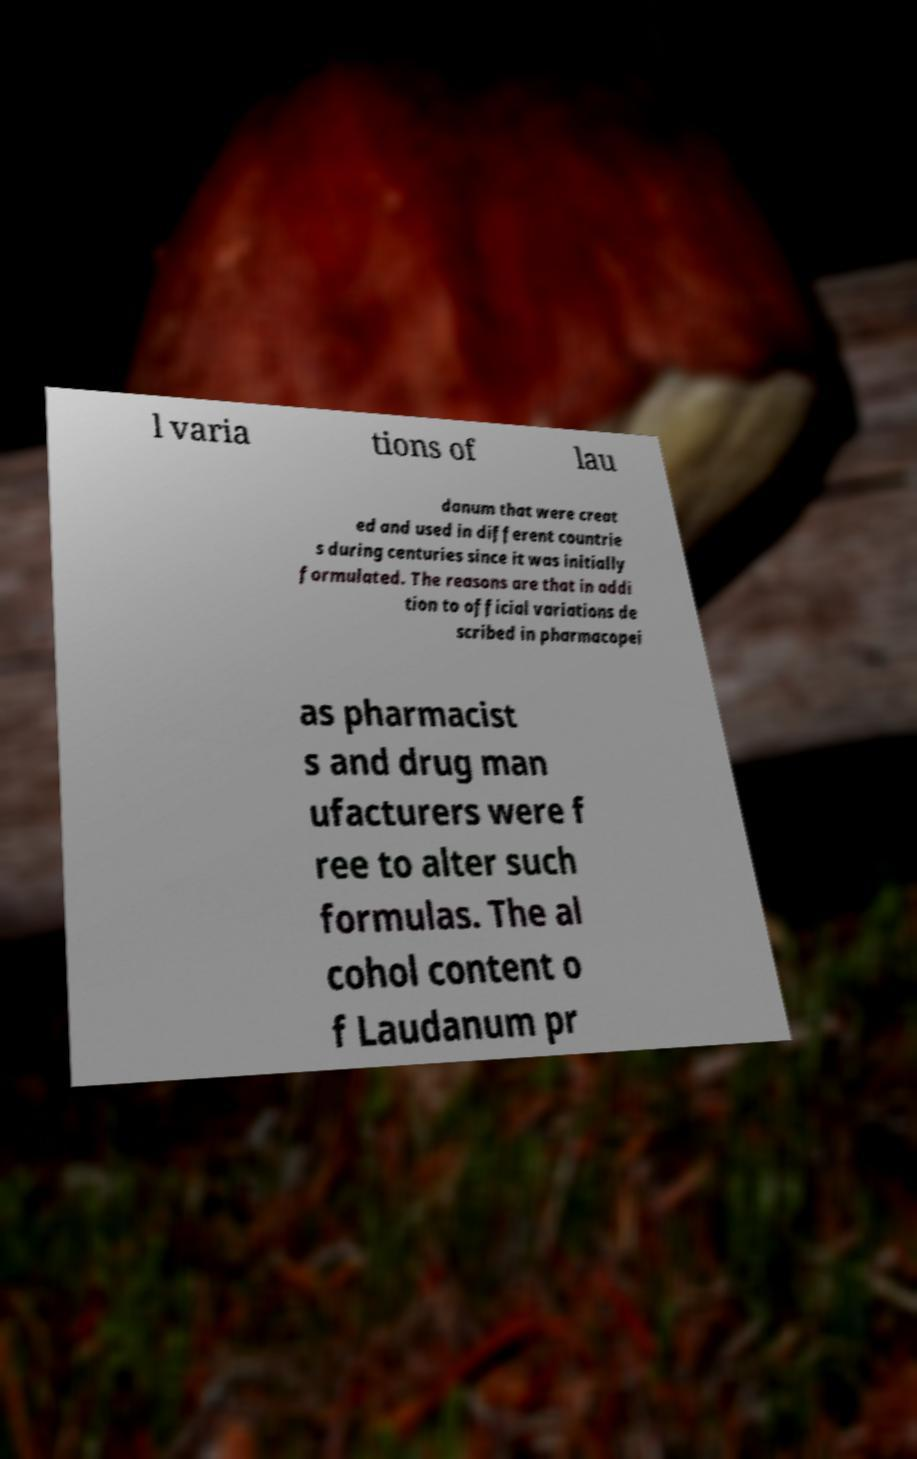Please read and relay the text visible in this image. What does it say? l varia tions of lau danum that were creat ed and used in different countrie s during centuries since it was initially formulated. The reasons are that in addi tion to official variations de scribed in pharmacopei as pharmacist s and drug man ufacturers were f ree to alter such formulas. The al cohol content o f Laudanum pr 